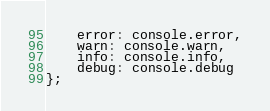<code> <loc_0><loc_0><loc_500><loc_500><_JavaScript_>	error: console.error,
	warn: console.warn,
	info: console.info,
	debug: console.debug
};
</code> 